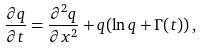<formula> <loc_0><loc_0><loc_500><loc_500>\frac { \partial q } { \partial t } = \frac { \partial ^ { 2 } q } { \partial x ^ { 2 } } + q ( \ln q + \Gamma ( t ) ) \, ,</formula> 